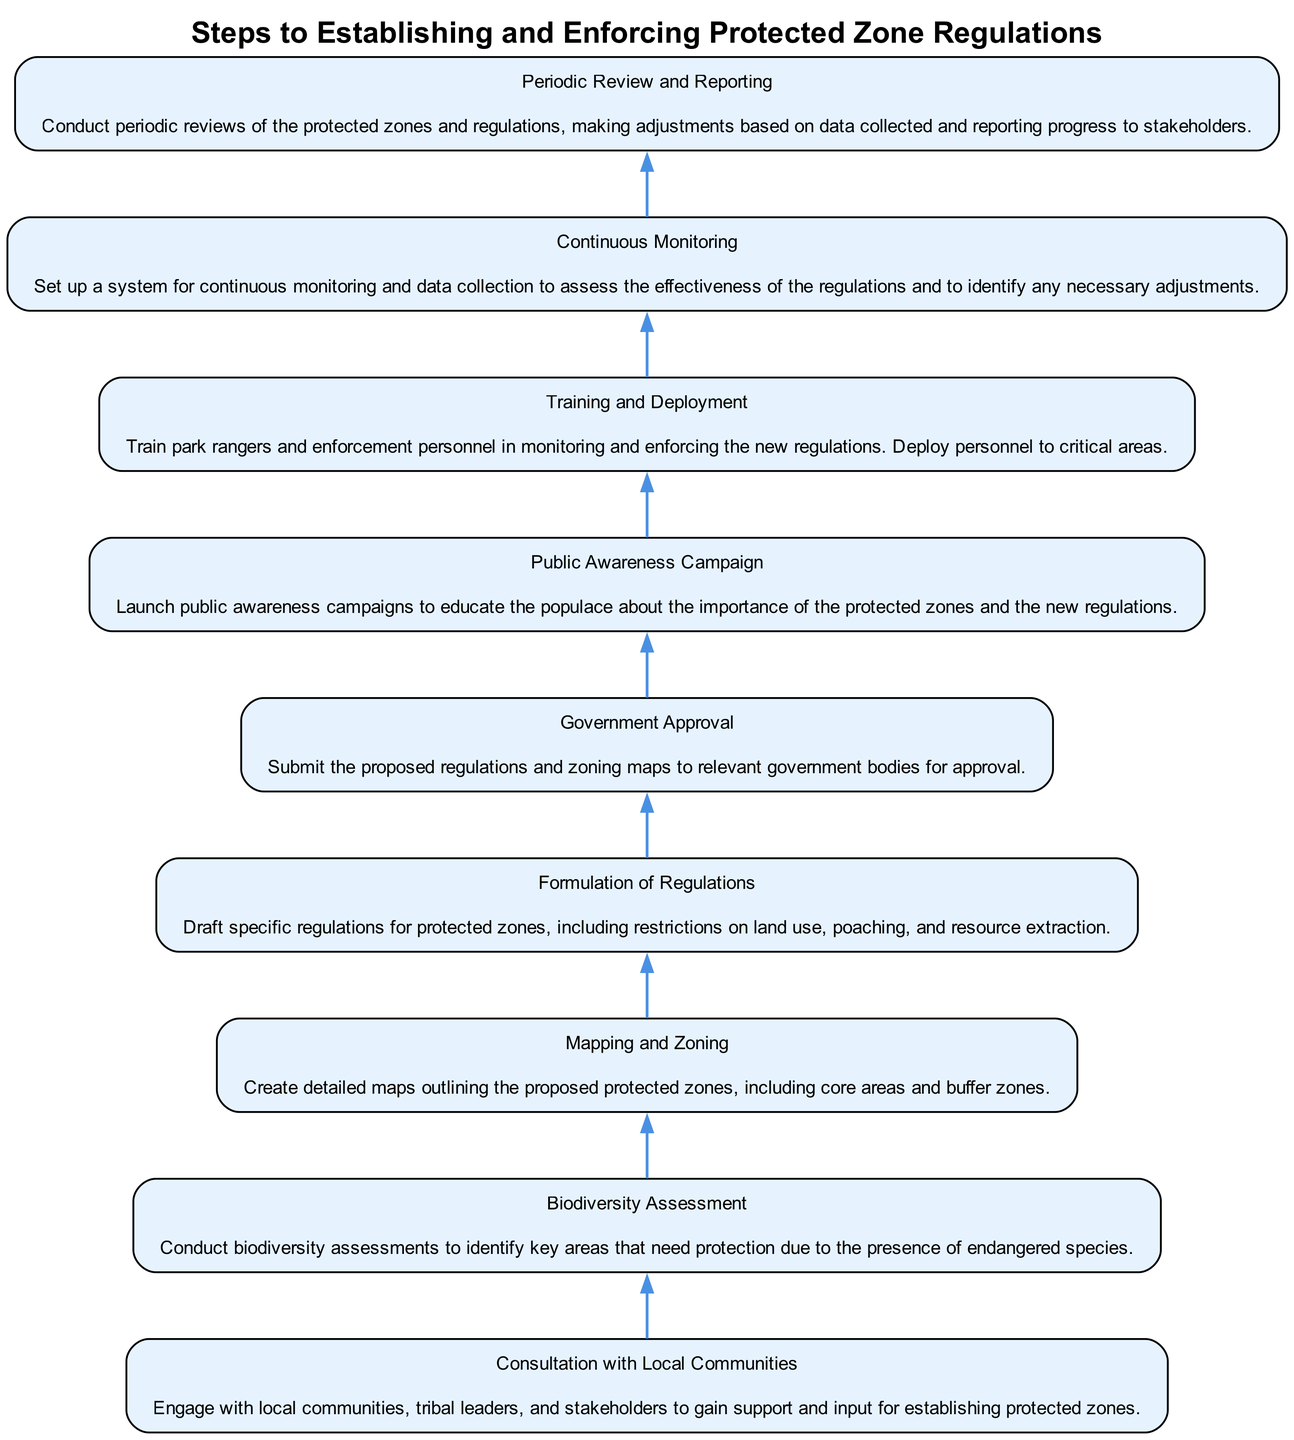What is the first step in the diagram? Referring to the flow chart, the first step listed at the bottom is "Consultation with Local Communities." This means it's the initial step to start the process of establishing protected zones.
Answer: Consultation with Local Communities How many total steps are there in the diagram? By counting each step listed in the flow chart, we see that there are a total of nine steps.
Answer: Nine What comes after "Biodiversity Assessment"? Following the "Biodiversity Assessment" step, the next step in the flow chart is "Mapping and Zoning." This establishes the sequence of actions based on the flow direction.
Answer: Mapping and Zoning What is the purpose of the "Public Awareness Campaign" step? The "Public Awareness Campaign" is aimed at educating the public about the importance of the protected zones and the new regulations that will come into effect. This step directly follows the formulation of regulations.
Answer: Educating the public Which step requires "Training and Deployment"? The step that requires "Training and Deployment" comes after the public awareness campaign. It involves training park rangers and enforcement personnel to monitor and enforce the new regulations successfully.
Answer: Training and Deployment What is the last step in the flow chart? The final step, located at the top of the flow chart, is "Periodic Review and Reporting." This signifies that the process is ongoing and requires regular assessments.
Answer: Periodic Review and Reporting What is the relationship between "Government Approval" and "Formulation of Regulations"? "Government Approval" is dependent on the successful completion of "Formulation of Regulations." This means that regulations must be drafted and submitted to the government before approval can be obtained.
Answer: Government Approval follows Formulation of Regulations How does "Continuous Monitoring" contribute to "Periodic Review and Reporting"? "Continuous Monitoring" is essential for "Periodic Review and Reporting" because it involves collecting data to evaluate the effectiveness of the regulations. This collected data is used in periodic reviews to improve and report on the progress of the protected zones.
Answer: Provides data for review 